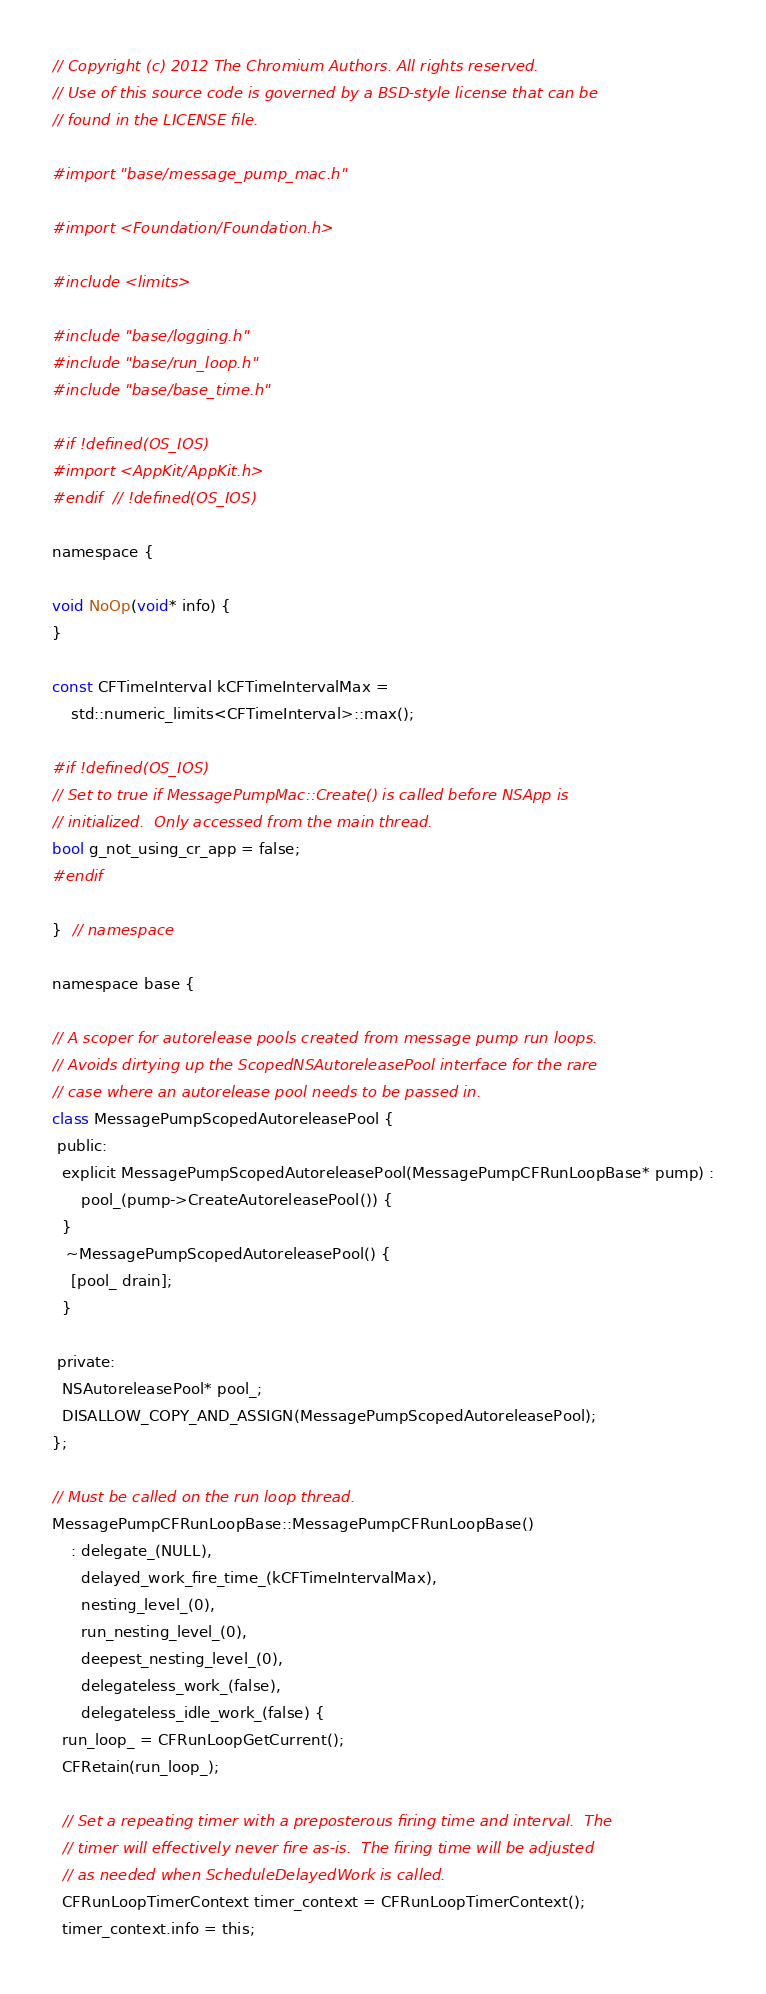Convert code to text. <code><loc_0><loc_0><loc_500><loc_500><_ObjectiveC_>// Copyright (c) 2012 The Chromium Authors. All rights reserved.
// Use of this source code is governed by a BSD-style license that can be
// found in the LICENSE file.

#import "base/message_pump_mac.h"

#import <Foundation/Foundation.h>

#include <limits>

#include "base/logging.h"
#include "base/run_loop.h"
#include "base/base_time.h"

#if !defined(OS_IOS)
#import <AppKit/AppKit.h>
#endif  // !defined(OS_IOS)

namespace {

void NoOp(void* info) {
}

const CFTimeInterval kCFTimeIntervalMax =
    std::numeric_limits<CFTimeInterval>::max();

#if !defined(OS_IOS)
// Set to true if MessagePumpMac::Create() is called before NSApp is
// initialized.  Only accessed from the main thread.
bool g_not_using_cr_app = false;
#endif

}  // namespace

namespace base {

// A scoper for autorelease pools created from message pump run loops.
// Avoids dirtying up the ScopedNSAutoreleasePool interface for the rare
// case where an autorelease pool needs to be passed in.
class MessagePumpScopedAutoreleasePool {
 public:
  explicit MessagePumpScopedAutoreleasePool(MessagePumpCFRunLoopBase* pump) :
      pool_(pump->CreateAutoreleasePool()) {
  }
   ~MessagePumpScopedAutoreleasePool() {
    [pool_ drain];
  }

 private:
  NSAutoreleasePool* pool_;
  DISALLOW_COPY_AND_ASSIGN(MessagePumpScopedAutoreleasePool);
};

// Must be called on the run loop thread.
MessagePumpCFRunLoopBase::MessagePumpCFRunLoopBase()
    : delegate_(NULL),
      delayed_work_fire_time_(kCFTimeIntervalMax),
      nesting_level_(0),
      run_nesting_level_(0),
      deepest_nesting_level_(0),
      delegateless_work_(false),
      delegateless_idle_work_(false) {
  run_loop_ = CFRunLoopGetCurrent();
  CFRetain(run_loop_);

  // Set a repeating timer with a preposterous firing time and interval.  The
  // timer will effectively never fire as-is.  The firing time will be adjusted
  // as needed when ScheduleDelayedWork is called.
  CFRunLoopTimerContext timer_context = CFRunLoopTimerContext();
  timer_context.info = this;</code> 